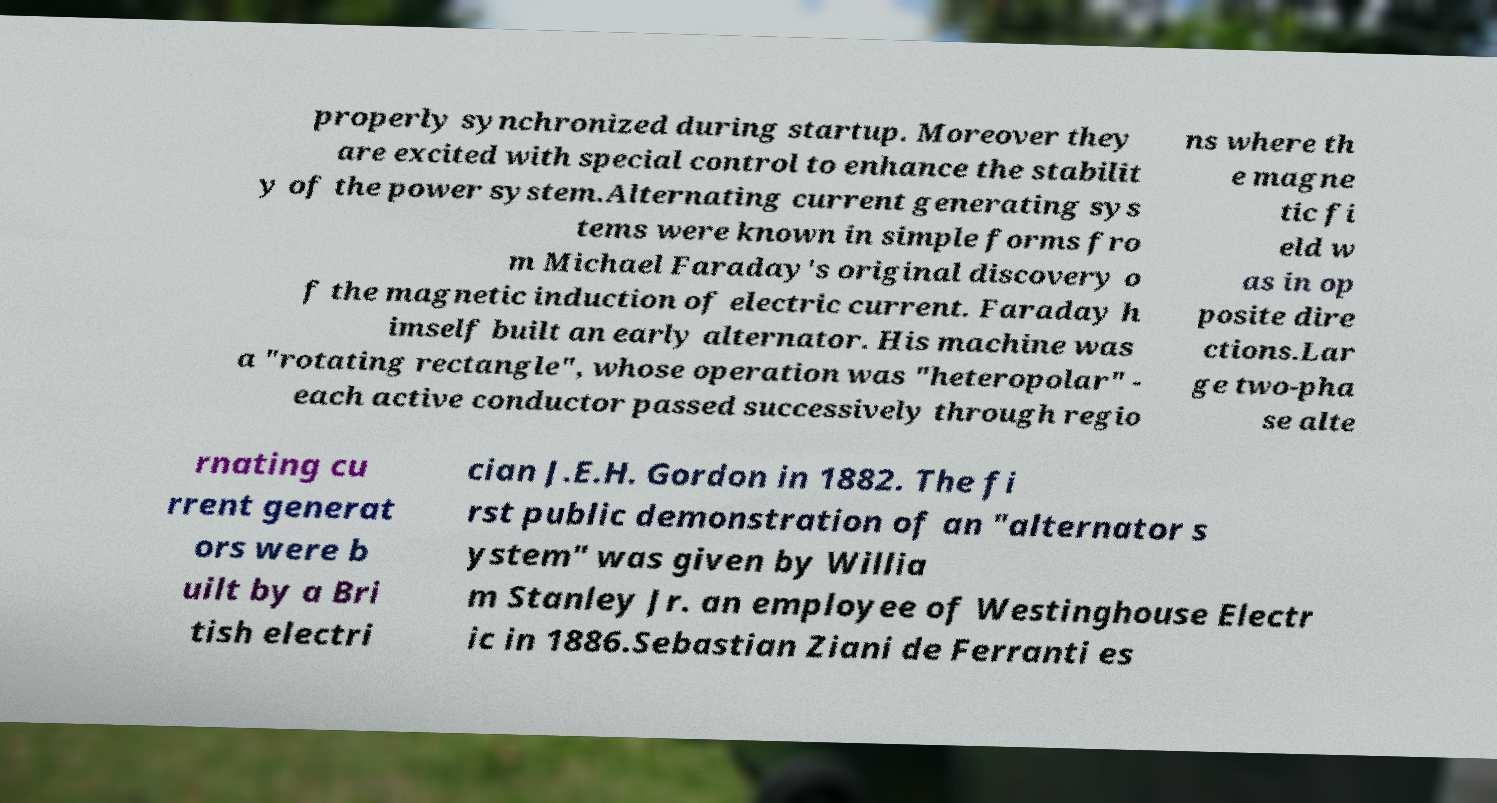For documentation purposes, I need the text within this image transcribed. Could you provide that? properly synchronized during startup. Moreover they are excited with special control to enhance the stabilit y of the power system.Alternating current generating sys tems were known in simple forms fro m Michael Faraday's original discovery o f the magnetic induction of electric current. Faraday h imself built an early alternator. His machine was a "rotating rectangle", whose operation was "heteropolar" - each active conductor passed successively through regio ns where th e magne tic fi eld w as in op posite dire ctions.Lar ge two-pha se alte rnating cu rrent generat ors were b uilt by a Bri tish electri cian J.E.H. Gordon in 1882. The fi rst public demonstration of an "alternator s ystem" was given by Willia m Stanley Jr. an employee of Westinghouse Electr ic in 1886.Sebastian Ziani de Ferranti es 